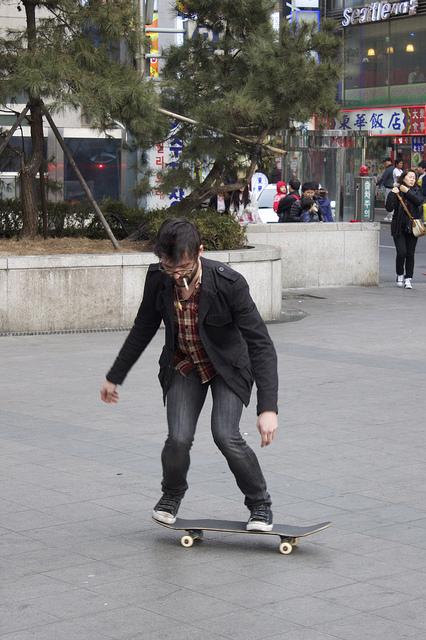Does he have cool shoes?
Be succinct. No. Is he smoking?
Answer briefly. Yes. What is he standing on?
Give a very brief answer. Skateboard. 